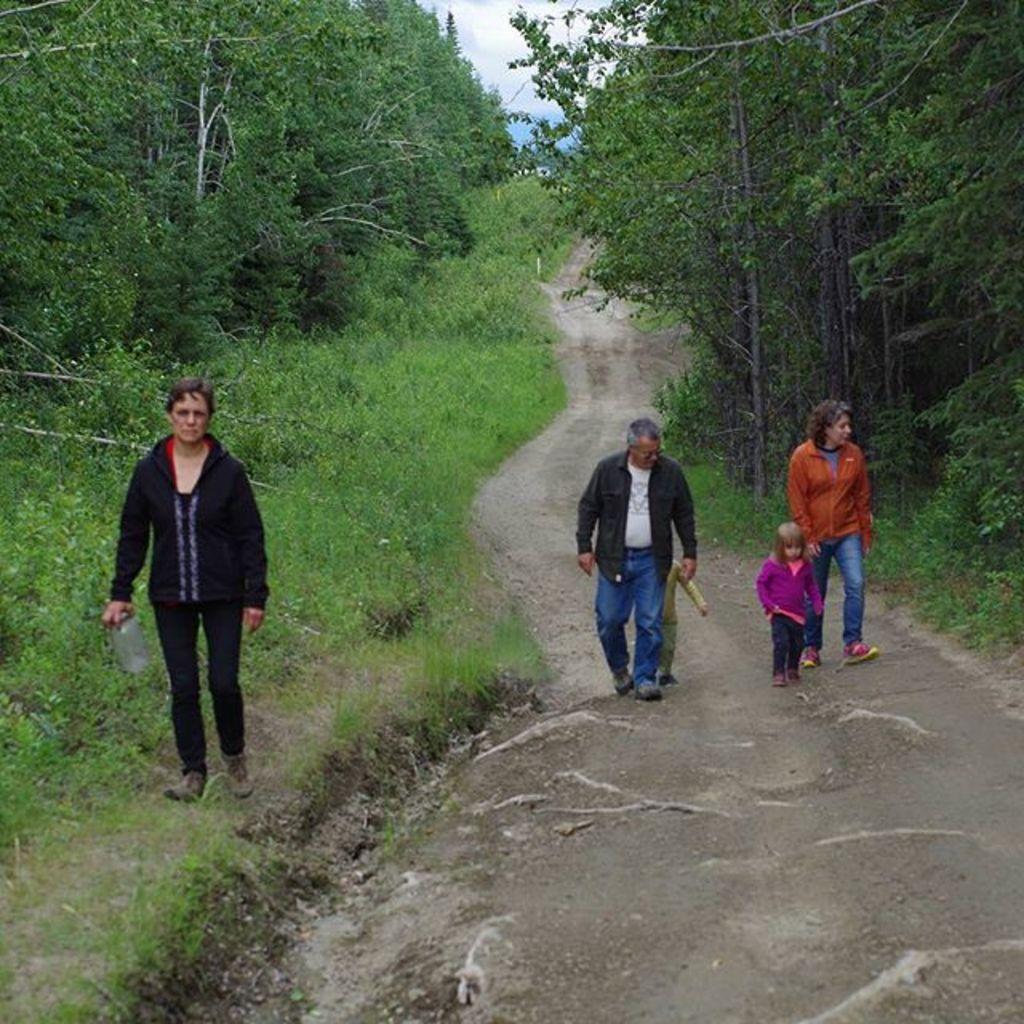How would you summarize this image in a sentence or two? On the right side of the image there are three persons walking on the road. On the left side of the mage on the ground there is grass and also there are small plants. In the background there are many trees. And also there is sky. 